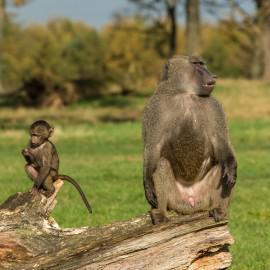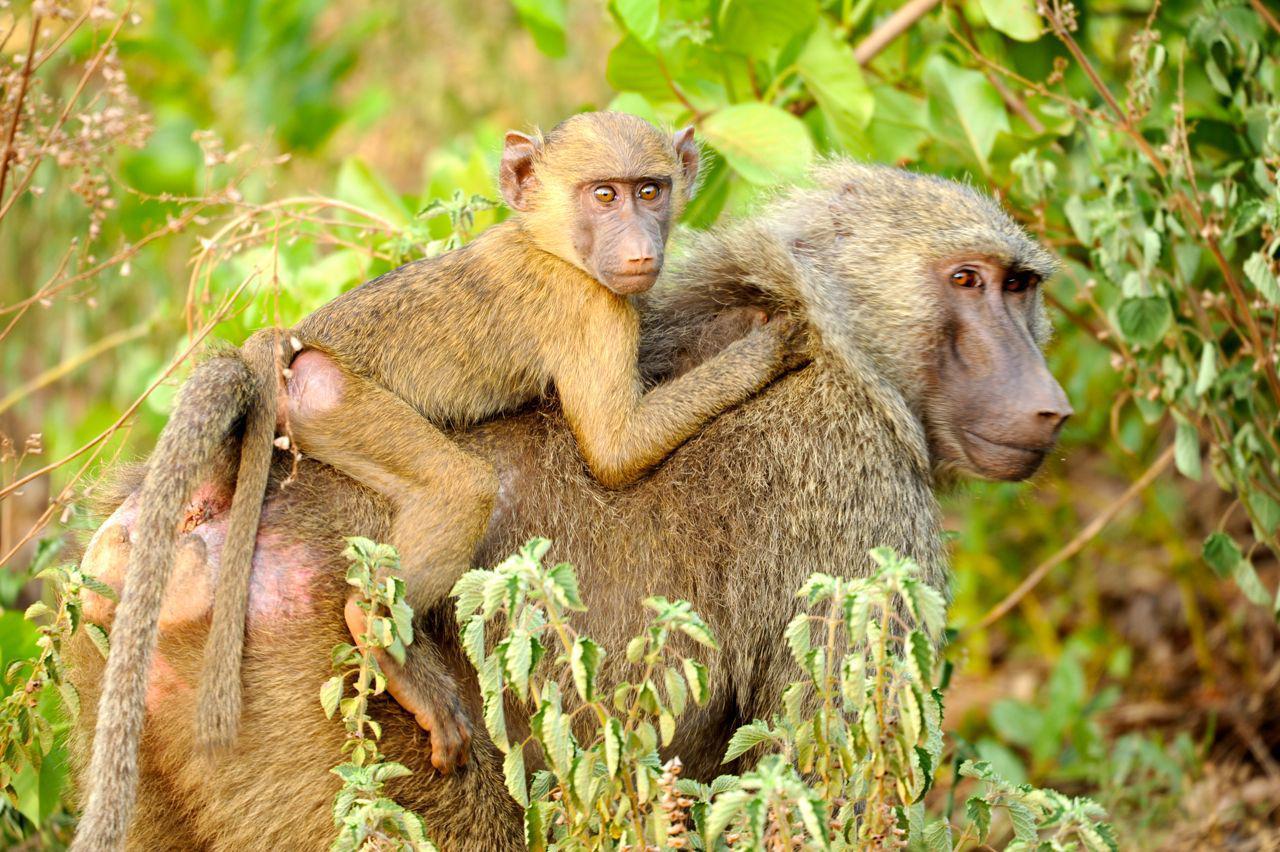The first image is the image on the left, the second image is the image on the right. Considering the images on both sides, is "An image containing no more than 3 apes includes a young baboon riding on an adult baboon." valid? Answer yes or no. Yes. The first image is the image on the left, the second image is the image on the right. Given the left and right images, does the statement "At least one of the images contains a baby monkey." hold true? Answer yes or no. Yes. 